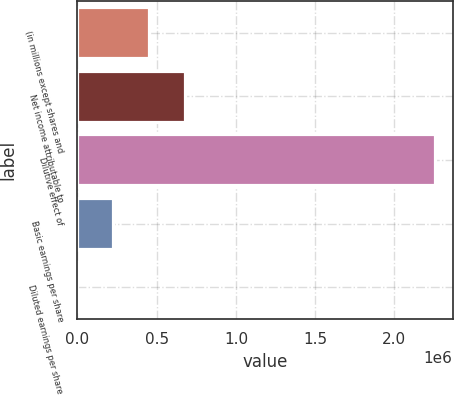<chart> <loc_0><loc_0><loc_500><loc_500><bar_chart><fcel>(in millions except shares and<fcel>Net income attributable to<fcel>Dilutive effect of<fcel>Basic earnings per share<fcel>Diluted earnings per share<nl><fcel>450911<fcel>676351<fcel>2.25443e+06<fcel>225471<fcel>30.23<nl></chart> 